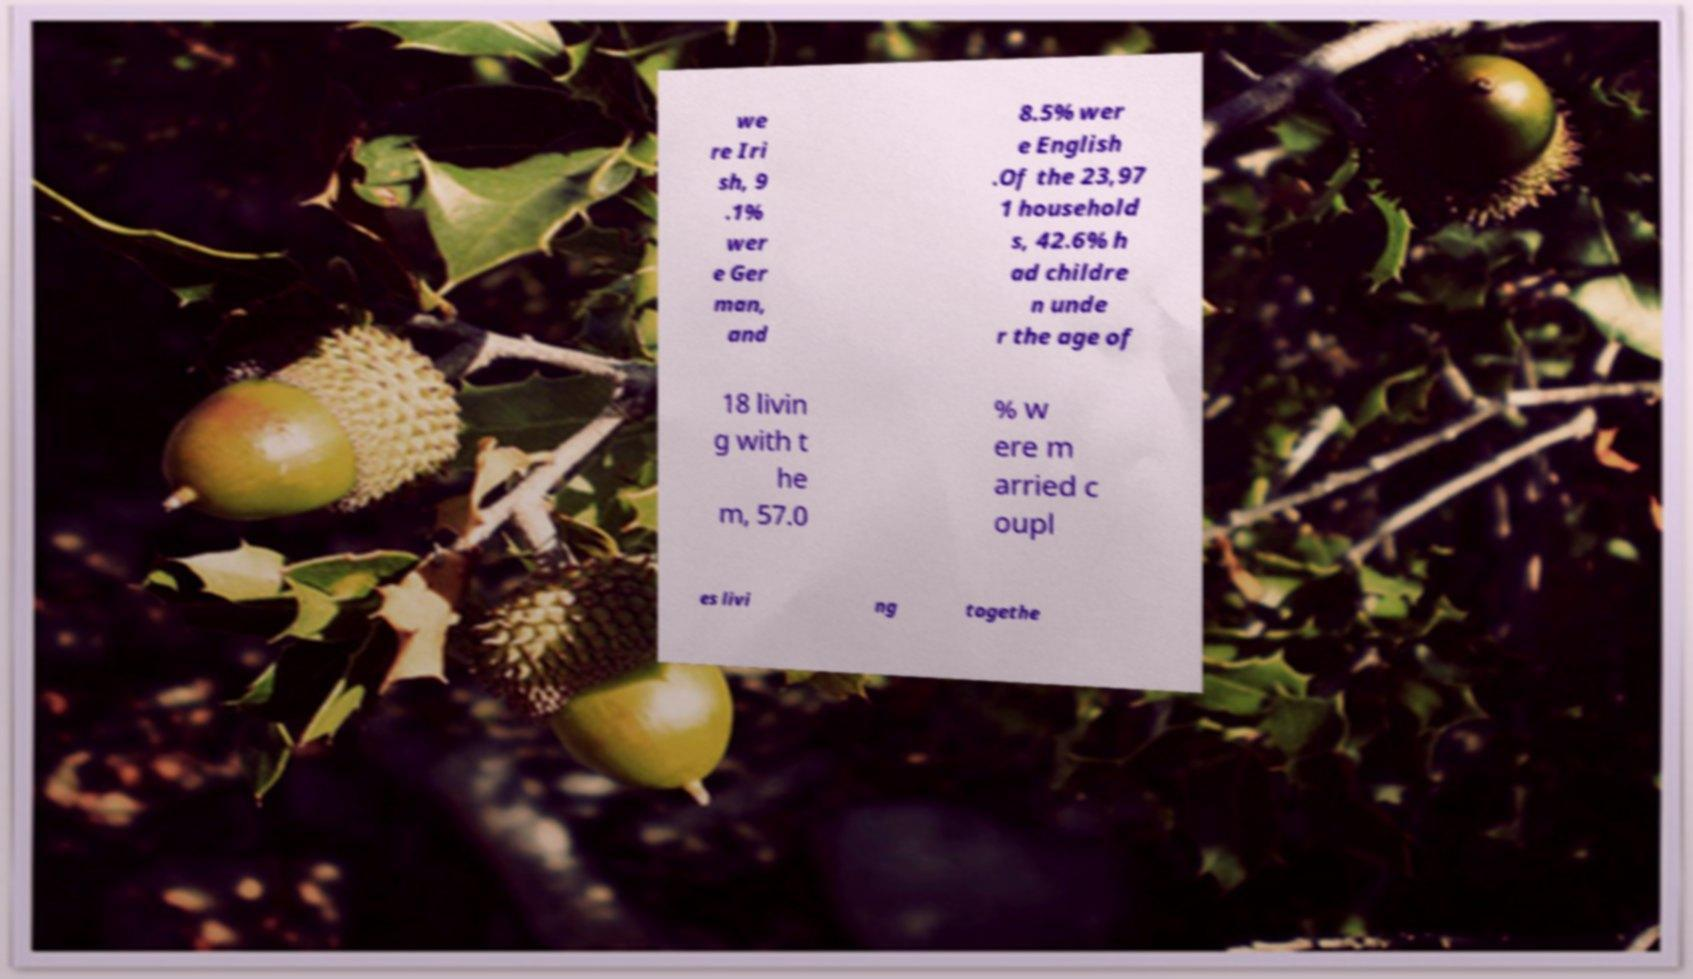Please read and relay the text visible in this image. What does it say? we re Iri sh, 9 .1% wer e Ger man, and 8.5% wer e English .Of the 23,97 1 household s, 42.6% h ad childre n unde r the age of 18 livin g with t he m, 57.0 % w ere m arried c oupl es livi ng togethe 